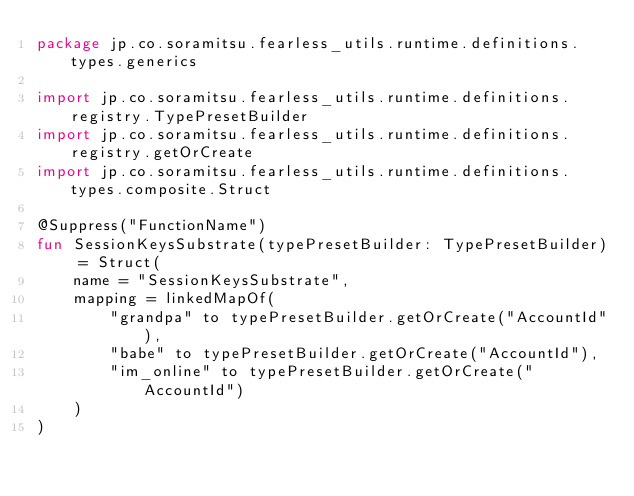<code> <loc_0><loc_0><loc_500><loc_500><_Kotlin_>package jp.co.soramitsu.fearless_utils.runtime.definitions.types.generics

import jp.co.soramitsu.fearless_utils.runtime.definitions.registry.TypePresetBuilder
import jp.co.soramitsu.fearless_utils.runtime.definitions.registry.getOrCreate
import jp.co.soramitsu.fearless_utils.runtime.definitions.types.composite.Struct

@Suppress("FunctionName")
fun SessionKeysSubstrate(typePresetBuilder: TypePresetBuilder) = Struct(
    name = "SessionKeysSubstrate",
    mapping = linkedMapOf(
        "grandpa" to typePresetBuilder.getOrCreate("AccountId"),
        "babe" to typePresetBuilder.getOrCreate("AccountId"),
        "im_online" to typePresetBuilder.getOrCreate("AccountId")
    )
)
</code> 